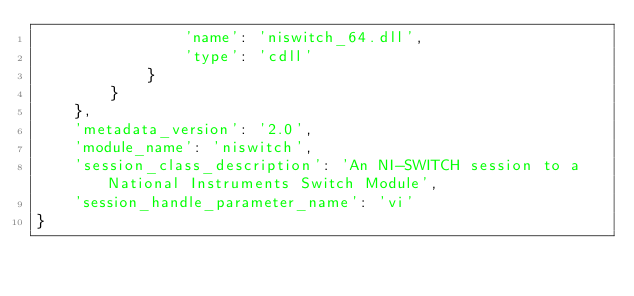Convert code to text. <code><loc_0><loc_0><loc_500><loc_500><_Python_>                'name': 'niswitch_64.dll',
                'type': 'cdll'
            }
        }
    },
    'metadata_version': '2.0',
    'module_name': 'niswitch',
    'session_class_description': 'An NI-SWITCH session to a National Instruments Switch Module',
    'session_handle_parameter_name': 'vi'
}
</code> 